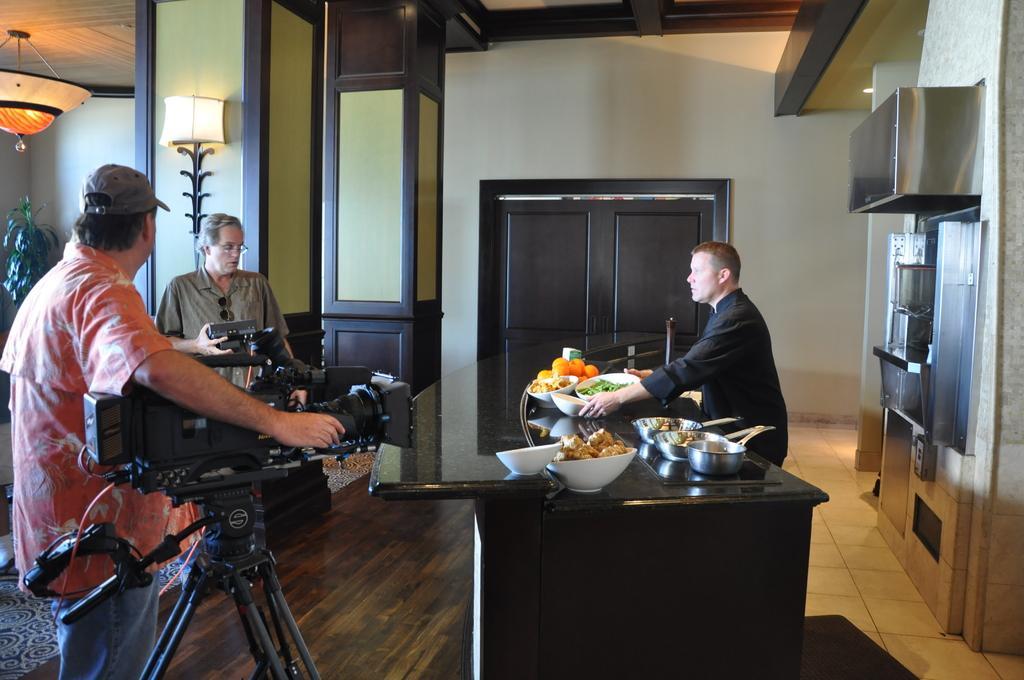How would you summarize this image in a sentence or two? In this image, there are a few people holding objects. We can see a table with some objects like bowls and food items. We can see the ground with some objects and a plant. We can also see the wall and some lights. We can also see a metal object attached to the wall on the right. 